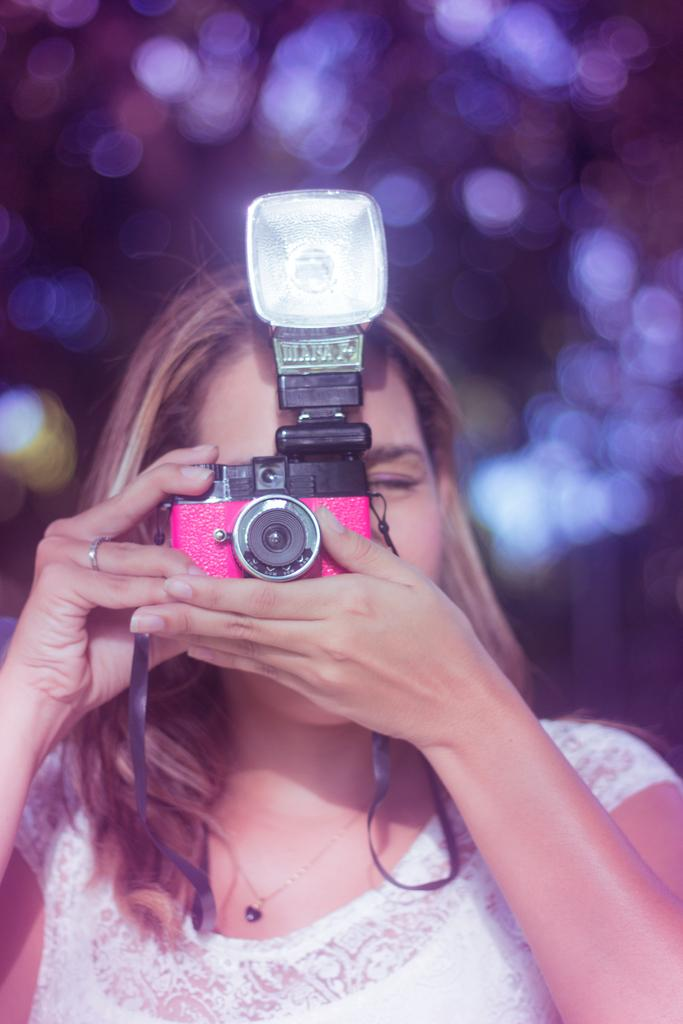Who is the main subject in the image? There is a woman in the image. What is the woman holding in her hand? The woman is holding a camera with her hand. What is the woman doing with the camera? The woman is taking a picture. Can you describe the background of the image? The background of the image is blurry. Is there a porter carrying luggage in the image? No, there is no porter carrying luggage in the image. Can you see a lake in the background of the image? No, there is no lake visible in the image. 